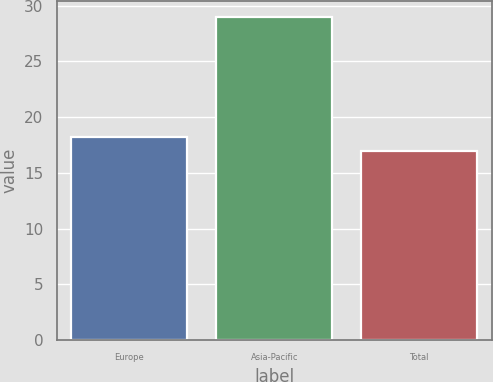<chart> <loc_0><loc_0><loc_500><loc_500><bar_chart><fcel>Europe<fcel>Asia-Pacific<fcel>Total<nl><fcel>18.2<fcel>29<fcel>17<nl></chart> 